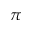Convert formula to latex. <formula><loc_0><loc_0><loc_500><loc_500>\pi</formula> 